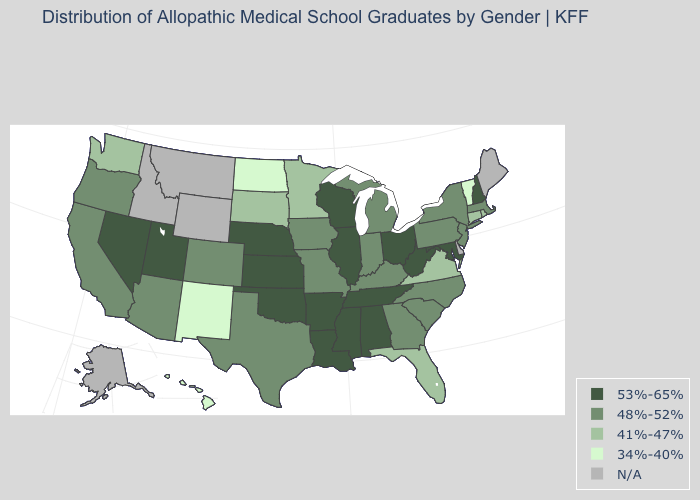What is the value of Maine?
Quick response, please. N/A. Which states have the lowest value in the USA?
Short answer required. Hawaii, New Mexico, North Dakota, Vermont. Name the states that have a value in the range N/A?
Answer briefly. Alaska, Delaware, Idaho, Maine, Montana, Wyoming. Which states have the lowest value in the South?
Quick response, please. Florida, Virginia. What is the highest value in the West ?
Give a very brief answer. 53%-65%. Name the states that have a value in the range 34%-40%?
Be succinct. Hawaii, New Mexico, North Dakota, Vermont. Name the states that have a value in the range 53%-65%?
Quick response, please. Alabama, Arkansas, Illinois, Kansas, Louisiana, Maryland, Mississippi, Nebraska, Nevada, New Hampshire, Ohio, Oklahoma, Tennessee, Utah, West Virginia, Wisconsin. What is the lowest value in the MidWest?
Write a very short answer. 34%-40%. Name the states that have a value in the range 41%-47%?
Short answer required. Connecticut, Florida, Minnesota, Rhode Island, South Dakota, Virginia, Washington. Which states have the highest value in the USA?
Give a very brief answer. Alabama, Arkansas, Illinois, Kansas, Louisiana, Maryland, Mississippi, Nebraska, Nevada, New Hampshire, Ohio, Oklahoma, Tennessee, Utah, West Virginia, Wisconsin. What is the value of Kentucky?
Short answer required. 48%-52%. What is the value of Alaska?
Write a very short answer. N/A. Among the states that border Illinois , does Wisconsin have the lowest value?
Keep it brief. No. Name the states that have a value in the range 41%-47%?
Give a very brief answer. Connecticut, Florida, Minnesota, Rhode Island, South Dakota, Virginia, Washington. What is the value of Utah?
Short answer required. 53%-65%. 